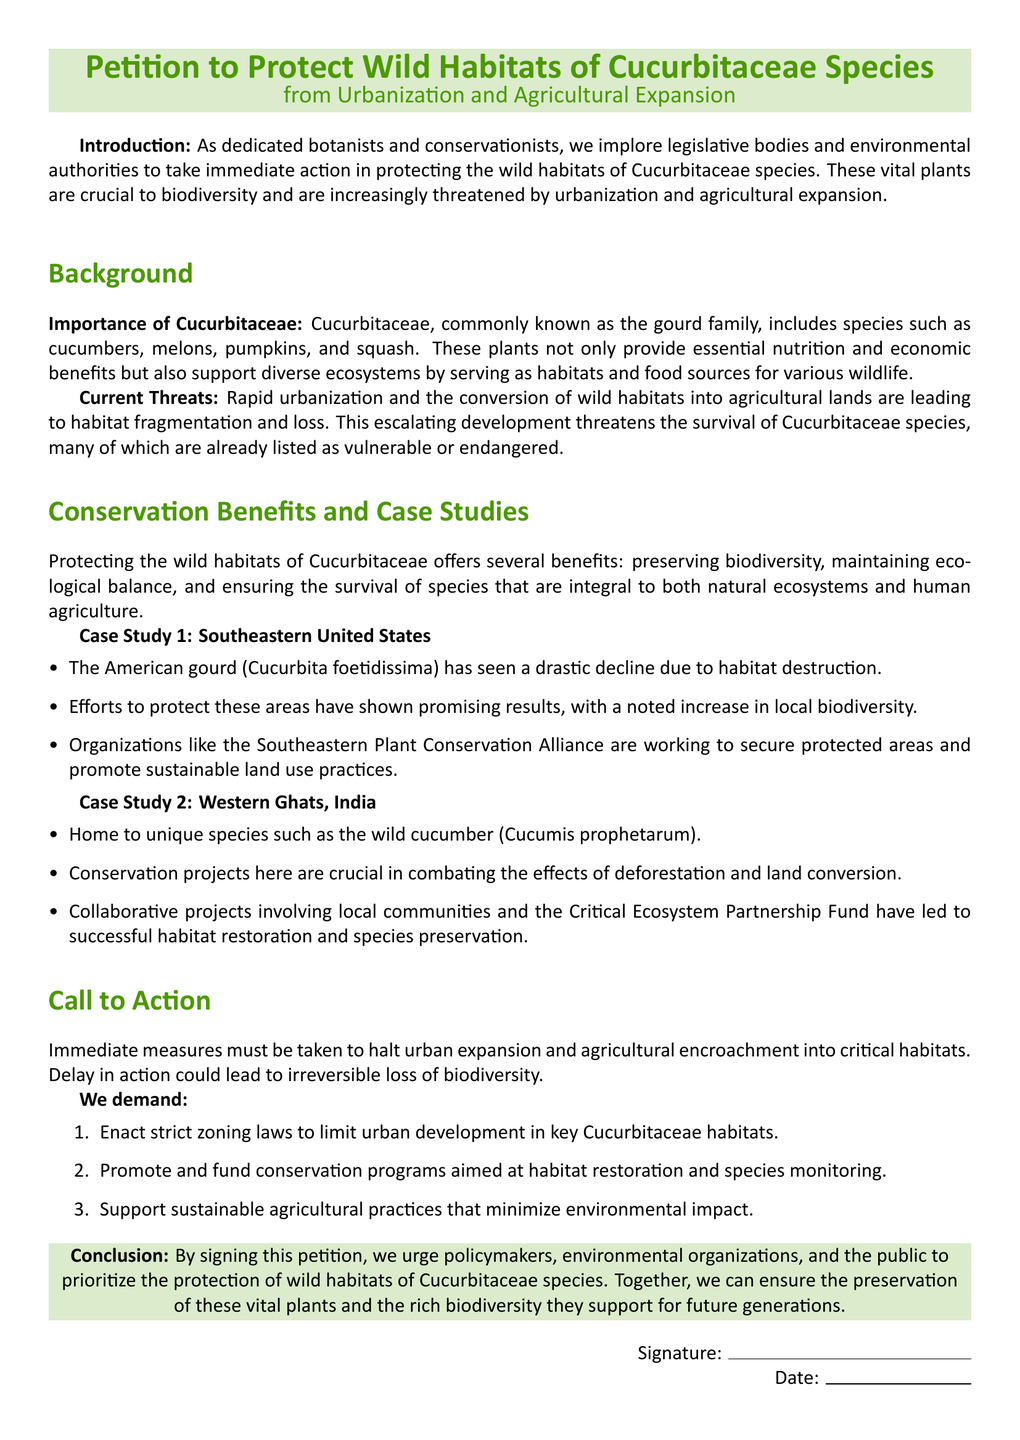what is the title of the petition? The title is explicitly stated at the beginning of the document as "Petition to Protect Wild Habitats of Cucurbitaceae Species from Urbanization and Agricultural Expansion."
Answer: Petition to Protect Wild Habitats of Cucurbitaceae Species from Urbanization and Agricultural Expansion what family do Cucurbitaceae species belong to? The document states that Cucurbitaceae is commonly known as the gourd family.
Answer: gourd family what is one example of a Cucurbitaceae species mentioned in the document? The document lists several examples, including cucumbers, melons, pumpkins, and squash.
Answer: cucumbers how many case studies are presented in the petition? The document explicitly mentions two case studies, indicating the efforts made to protect habitats.
Answer: 2 what is one demand made in the "Call to Action" section? The document outlines several demands, one of which is to "Enact strict zoning laws to limit urban development in key Cucurbitaceae habitats."
Answer: Enact strict zoning laws to limit urban development in key Cucurbitaceae habitats which region is associated with the American gourd case study? The document specifies that the case study related to the American gourd is located in the Southeastern United States.
Answer: Southeastern United States what ecological benefit does protecting Cucurbitaceae provide? The document highlights that protecting these habitats helps preserve biodiversity.
Answer: preserving biodiversity who is mentioned as working for conservation in the Southeastern United States? The document references the Southeastern Plant Conservation Alliance as working to secure protected areas.
Answer: Southeastern Plant Conservation Alliance 